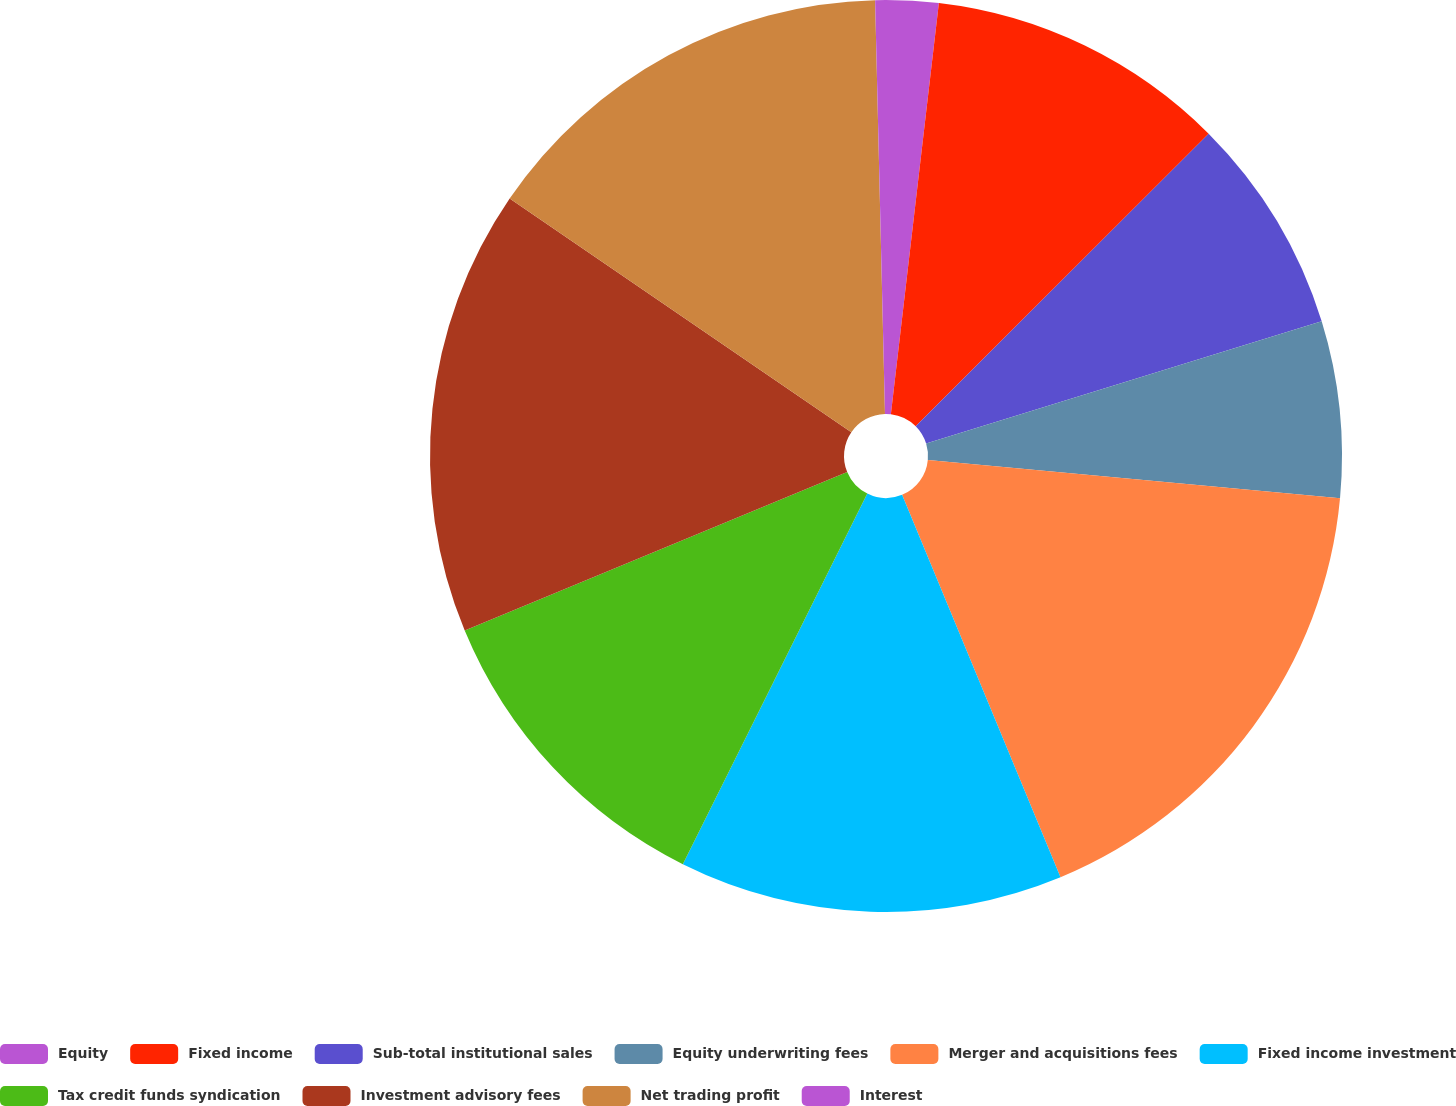<chart> <loc_0><loc_0><loc_500><loc_500><pie_chart><fcel>Equity<fcel>Fixed income<fcel>Sub-total institutional sales<fcel>Equity underwriting fees<fcel>Merger and acquisitions fees<fcel>Fixed income investment<fcel>Tax credit funds syndication<fcel>Investment advisory fees<fcel>Net trading profit<fcel>Interest<nl><fcel>1.85%<fcel>10.66%<fcel>7.72%<fcel>6.25%<fcel>17.27%<fcel>13.6%<fcel>11.4%<fcel>15.8%<fcel>15.07%<fcel>0.38%<nl></chart> 